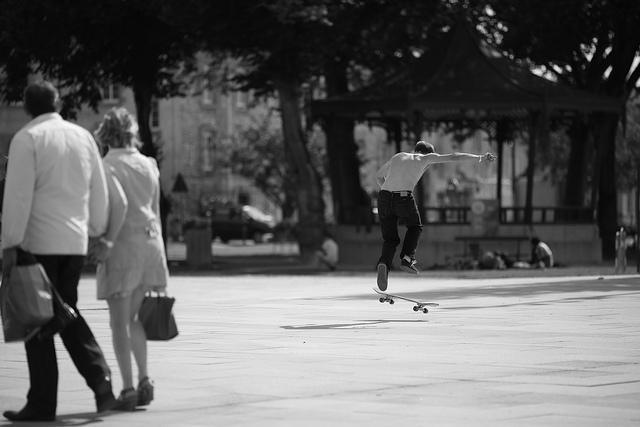How many skateboards are in the picture?
Give a very brief answer. 1. How many people are in the picture?
Give a very brief answer. 3. How many people are there?
Give a very brief answer. 3. 